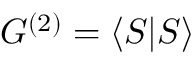Convert formula to latex. <formula><loc_0><loc_0><loc_500><loc_500>G ^ { ( 2 ) } = \langle S | S \rangle</formula> 